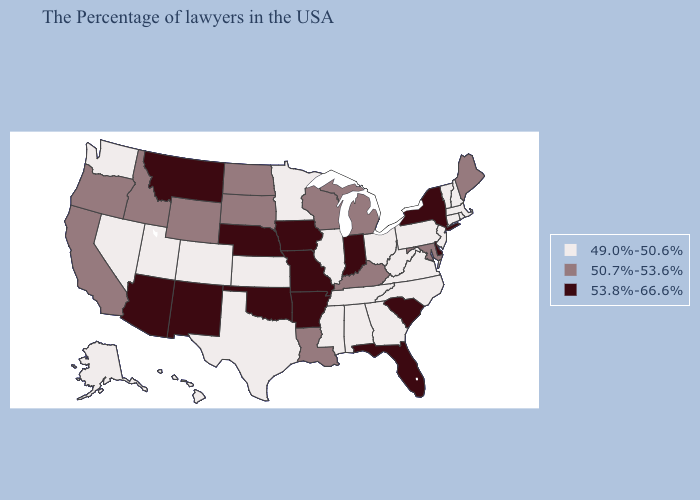What is the value of Tennessee?
Write a very short answer. 49.0%-50.6%. Does Maryland have the highest value in the USA?
Give a very brief answer. No. Name the states that have a value in the range 49.0%-50.6%?
Answer briefly. Massachusetts, Rhode Island, New Hampshire, Vermont, Connecticut, New Jersey, Pennsylvania, Virginia, North Carolina, West Virginia, Ohio, Georgia, Alabama, Tennessee, Illinois, Mississippi, Minnesota, Kansas, Texas, Colorado, Utah, Nevada, Washington, Alaska, Hawaii. What is the highest value in states that border Indiana?
Short answer required. 50.7%-53.6%. What is the lowest value in the USA?
Be succinct. 49.0%-50.6%. How many symbols are there in the legend?
Short answer required. 3. Does the map have missing data?
Be succinct. No. How many symbols are there in the legend?
Keep it brief. 3. Does Nevada have the lowest value in the West?
Answer briefly. Yes. Among the states that border Minnesota , which have the highest value?
Write a very short answer. Iowa. Among the states that border Colorado , does Kansas have the lowest value?
Give a very brief answer. Yes. Does New York have the same value as Kansas?
Concise answer only. No. Name the states that have a value in the range 49.0%-50.6%?
Short answer required. Massachusetts, Rhode Island, New Hampshire, Vermont, Connecticut, New Jersey, Pennsylvania, Virginia, North Carolina, West Virginia, Ohio, Georgia, Alabama, Tennessee, Illinois, Mississippi, Minnesota, Kansas, Texas, Colorado, Utah, Nevada, Washington, Alaska, Hawaii. What is the value of West Virginia?
Answer briefly. 49.0%-50.6%. What is the highest value in the USA?
Be succinct. 53.8%-66.6%. 